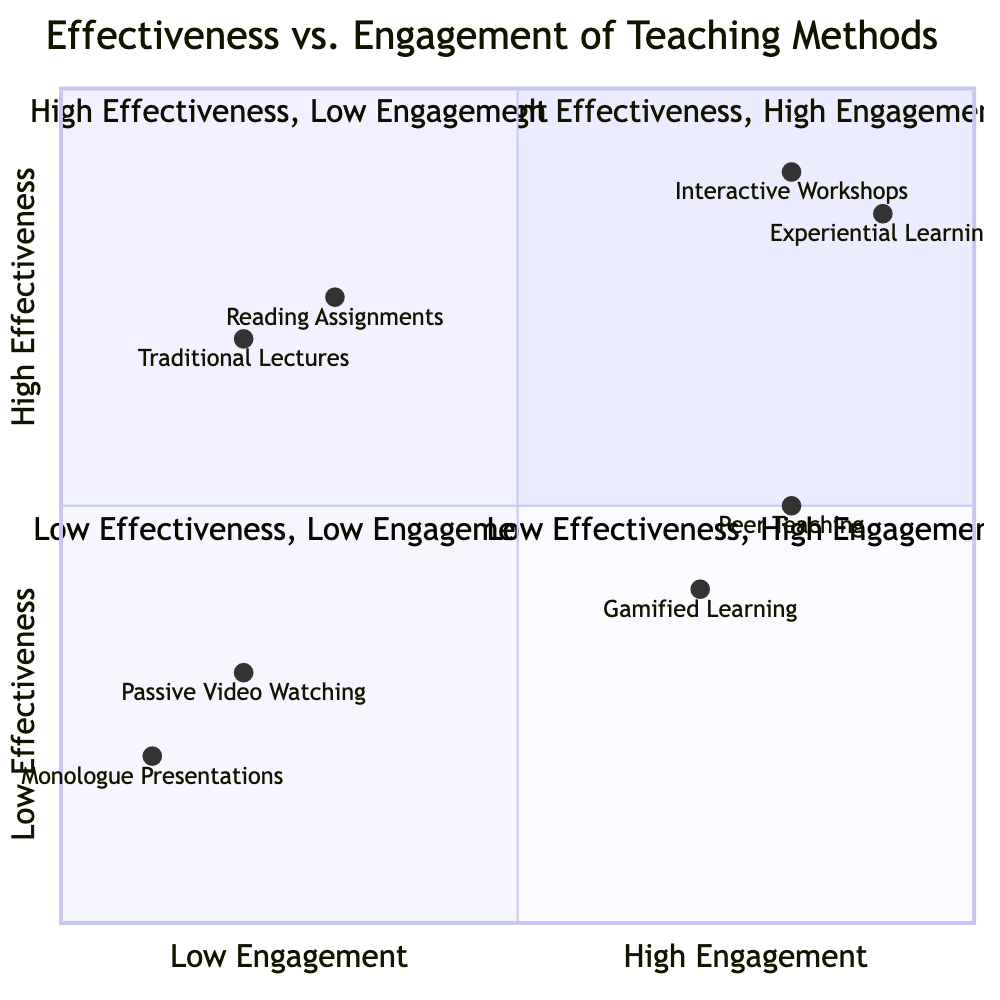What are the elements in the High Effectiveness, High Engagement quadrant? The diagram lists "Interactive Workshops" and "Experiential Learning" as the elements in the "High Effectiveness, High Engagement" quadrant.
Answer: Interactive Workshops, Experiential Learning How many elements are in the Low Effectiveness, Low Engagement quadrant? The quadrant contains two elements: "Monologue Presentations" and "Passive Video Watching." Therefore, the count of elements is two.
Answer: 2 What is the engagement level of Traditional Lectures? The diagram indicates that "Traditional Lectures" have an engagement level represented by a coordinate of [0.2, 0.7], where 0.2 refers to low engagement.
Answer: Low Engagement Which method has the highest effectiveness? "Experiential Learning" has the highest effectiveness with a value of 0.9, which is greater than all other methods in the diagram.
Answer: Experiential Learning What is the overall effectiveness level in the Low Effectiveness, High Engagement quadrant? This quadrant includes "Gamified Learning" (0.4) and "Peer Teaching" (0.5); hence, the overall effectiveness level is represented by the average of these values, but the highest effectiveness in this quadrant is 0.5 from Peer Teaching.
Answer: 0.5 What teaching method is the least effective? "Monologue Presentations" has the lowest effectiveness level with a value of 0.2 in the diagram.
Answer: Monologue Presentations How many methods are categorized under Low Effectiveness? The quadrant chart includes three methods classified under low effectiveness: "Monologue Presentations," "Passive Video Watching," and "Gamified Learning." Therefore, it contains three methods.
Answer: 3 Which quadrant contains Peer Teaching? "Peer Teaching" is located in the "Low Effectiveness, High Engagement" quadrant as shown in the diagram.
Answer: Low Effectiveness, High Engagement Which teaching method has the highest level of engagement? "Interactive Workshops" displays the highest engagement level with a value of 0.9 in the diagram.
Answer: Interactive Workshops 